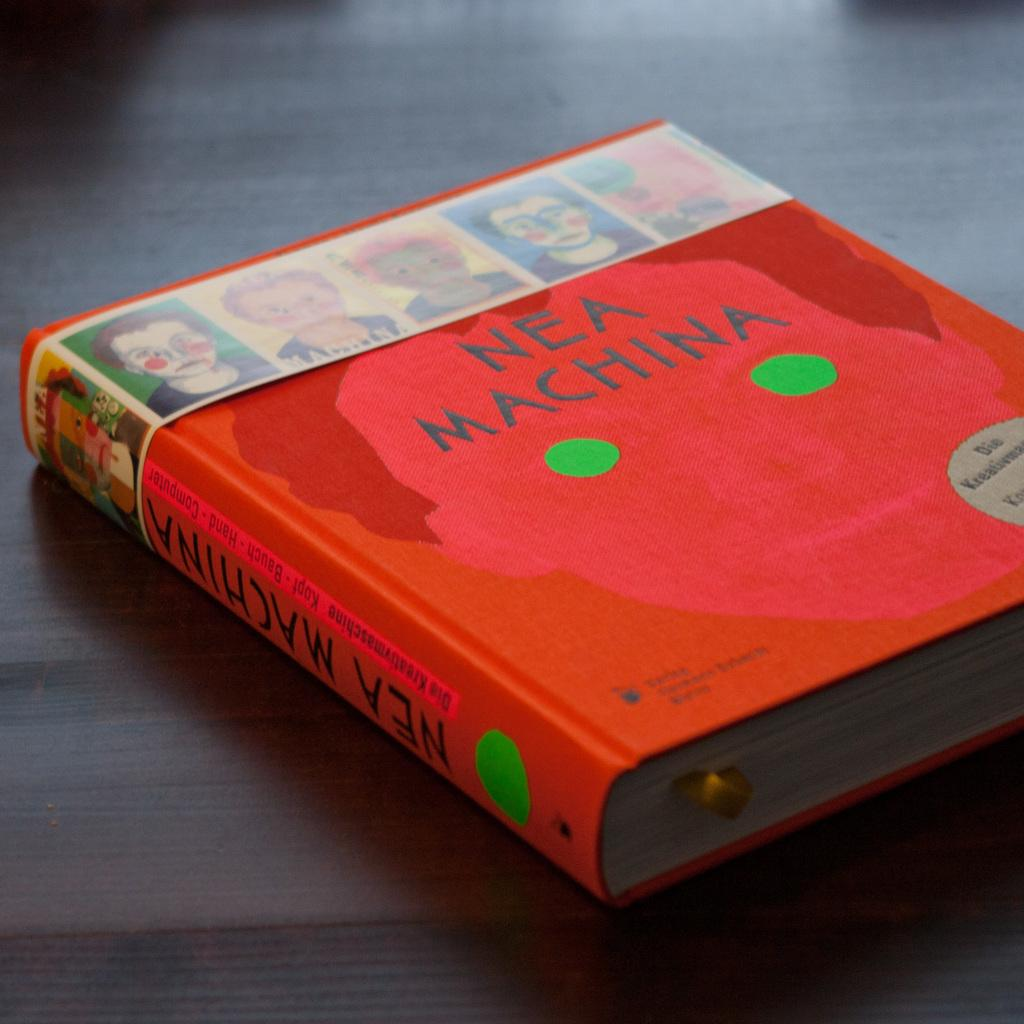<image>
Write a terse but informative summary of the picture. A book titled Nea Machina has green stickers on the front 